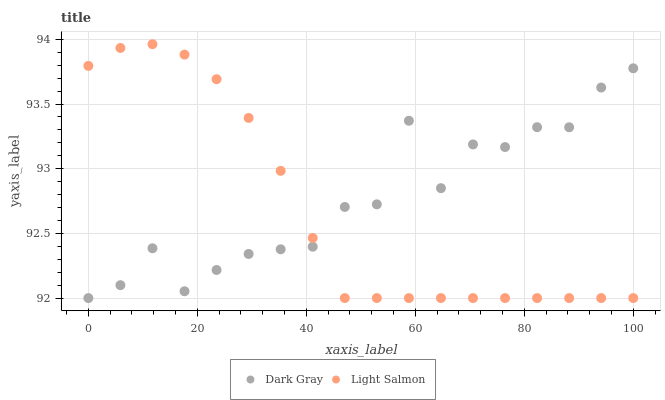Does Light Salmon have the minimum area under the curve?
Answer yes or no. Yes. Does Dark Gray have the maximum area under the curve?
Answer yes or no. Yes. Does Light Salmon have the maximum area under the curve?
Answer yes or no. No. Is Light Salmon the smoothest?
Answer yes or no. Yes. Is Dark Gray the roughest?
Answer yes or no. Yes. Is Light Salmon the roughest?
Answer yes or no. No. Does Dark Gray have the lowest value?
Answer yes or no. Yes. Does Light Salmon have the highest value?
Answer yes or no. Yes. Does Light Salmon intersect Dark Gray?
Answer yes or no. Yes. Is Light Salmon less than Dark Gray?
Answer yes or no. No. Is Light Salmon greater than Dark Gray?
Answer yes or no. No. 